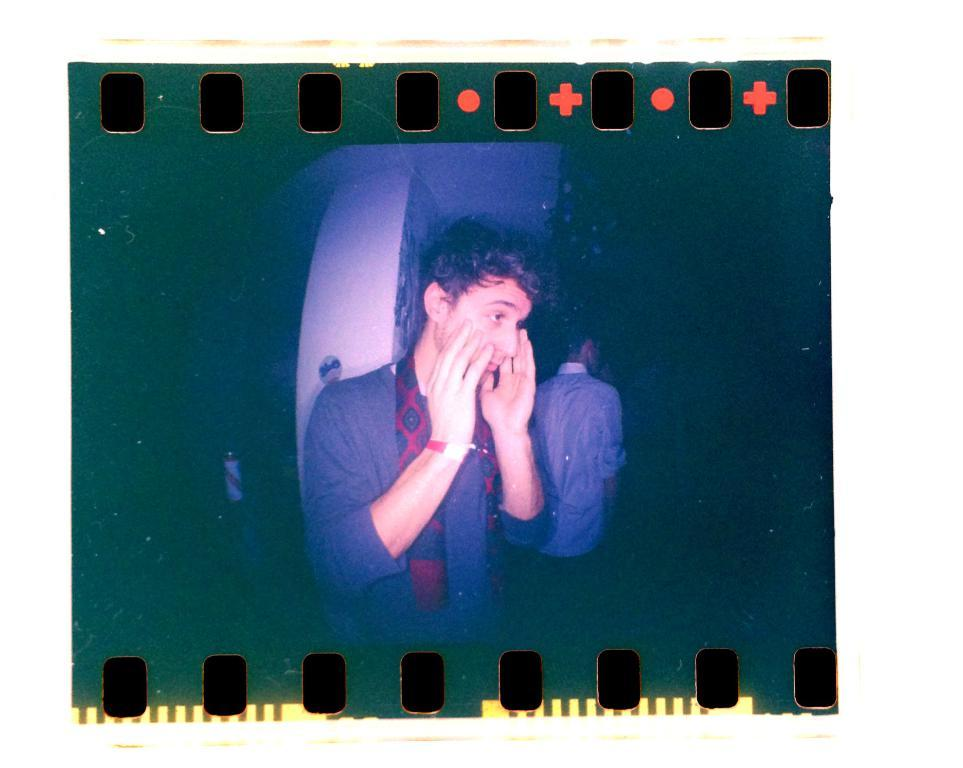How many people are in the image? There are two men in the image. Where are the men located in the image? The men are in the center of the image. What can be seen in the background of the image? There is a pillar in the background of the image. What type of map is the men discussing in the image? There is no map present in the image; the men are not discussing anything. 